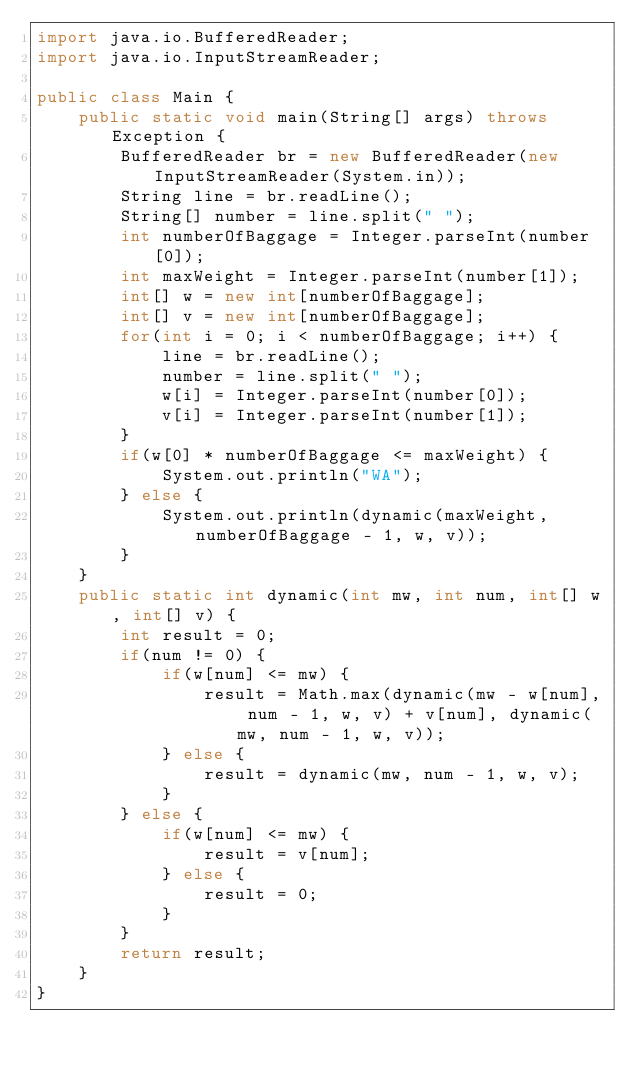<code> <loc_0><loc_0><loc_500><loc_500><_Java_>import java.io.BufferedReader;
import java.io.InputStreamReader;
 
public class Main {
    public static void main(String[] args) throws Exception {
        BufferedReader br = new BufferedReader(new InputStreamReader(System.in));
        String line = br.readLine();
        String[] number = line.split(" ");
		int numberOfBaggage = Integer.parseInt(number[0]);
		int maxWeight = Integer.parseInt(number[1]);
		int[] w = new int[numberOfBaggage];
		int[] v = new int[numberOfBaggage];
		for(int i = 0; i < numberOfBaggage; i++) {
            line = br.readLine();
            number = line.split(" ");
		    w[i] = Integer.parseInt(number[0]);
		    v[i] = Integer.parseInt(number[1]);
		}
        if(w[0] * numberOfBaggage <= maxWeight) {
            System.out.println("WA");
        } else {
		    System.out.println(dynamic(maxWeight, numberOfBaggage - 1, w, v));
        }
	}
	public static int dynamic(int mw, int num, int[] w, int[] v) {
		int result = 0;
		if(num != 0) {
			if(w[num] <= mw) {
				result = Math.max(dynamic(mw - w[num], num - 1, w, v) + v[num], dynamic(mw, num - 1, w, v));
			} else {
				result = dynamic(mw, num - 1, w, v);
			}
		} else {
			if(w[num] <= mw) {
				result = v[num];
			} else {
				result = 0;
			}
		}
		return result;
	}
}</code> 